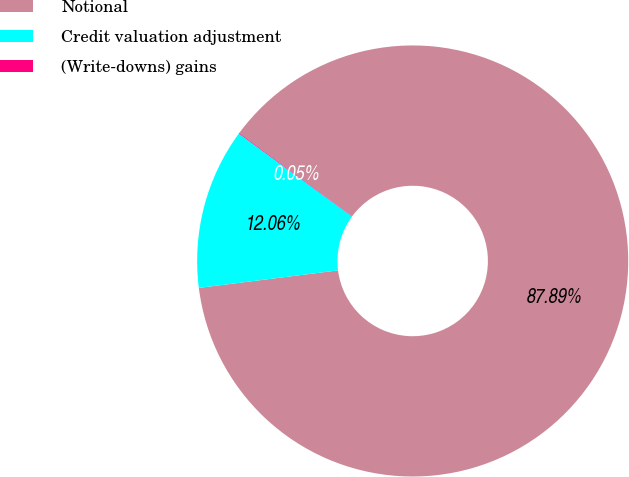<chart> <loc_0><loc_0><loc_500><loc_500><pie_chart><fcel>Notional<fcel>Credit valuation adjustment<fcel>(Write-downs) gains<nl><fcel>87.88%<fcel>12.06%<fcel>0.05%<nl></chart> 